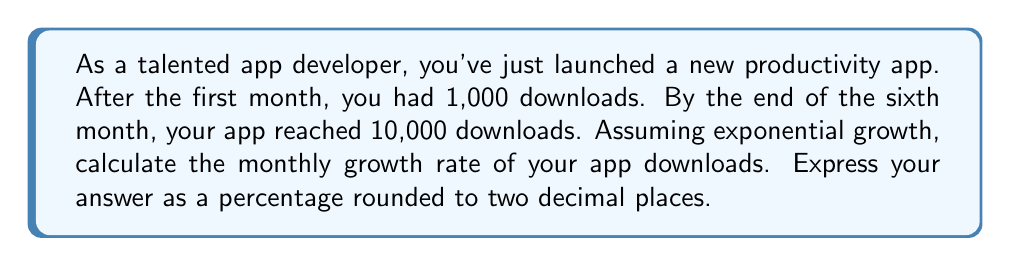Can you answer this question? Let's approach this step-by-step using the exponential growth formula and logarithms:

1) The exponential growth formula is:
   $A = P(1 + r)^t$
   Where:
   $A$ is the final amount
   $P$ is the initial amount
   $r$ is the growth rate (in decimal form)
   $t$ is the time period

2) We know:
   $P = 1,000$ (initial downloads)
   $A = 10,000$ (final downloads)
   $t = 5$ (5 months of growth)

3) Plugging these into our formula:
   $10,000 = 1,000(1 + r)^5$

4) Divide both sides by 1,000:
   $10 = (1 + r)^5$

5) Take the natural log of both sides:
   $\ln(10) = \ln((1 + r)^5)$

6) Use the logarithm property $\ln(x^n) = n\ln(x)$:
   $\ln(10) = 5\ln(1 + r)$

7) Divide both sides by 5:
   $\frac{\ln(10)}{5} = \ln(1 + r)$

8) Take $e$ to the power of both sides:
   $e^{\frac{\ln(10)}{5}} = e^{\ln(1 + r)}$

9) Simplify the right side:
   $e^{\frac{\ln(10)}{5}} = 1 + r$

10) Subtract 1 from both sides:
    $e^{\frac{\ln(10)}{5}} - 1 = r$

11) Calculate:
    $r \approx 0.5848$ or 58.48%
Answer: 58.48% 